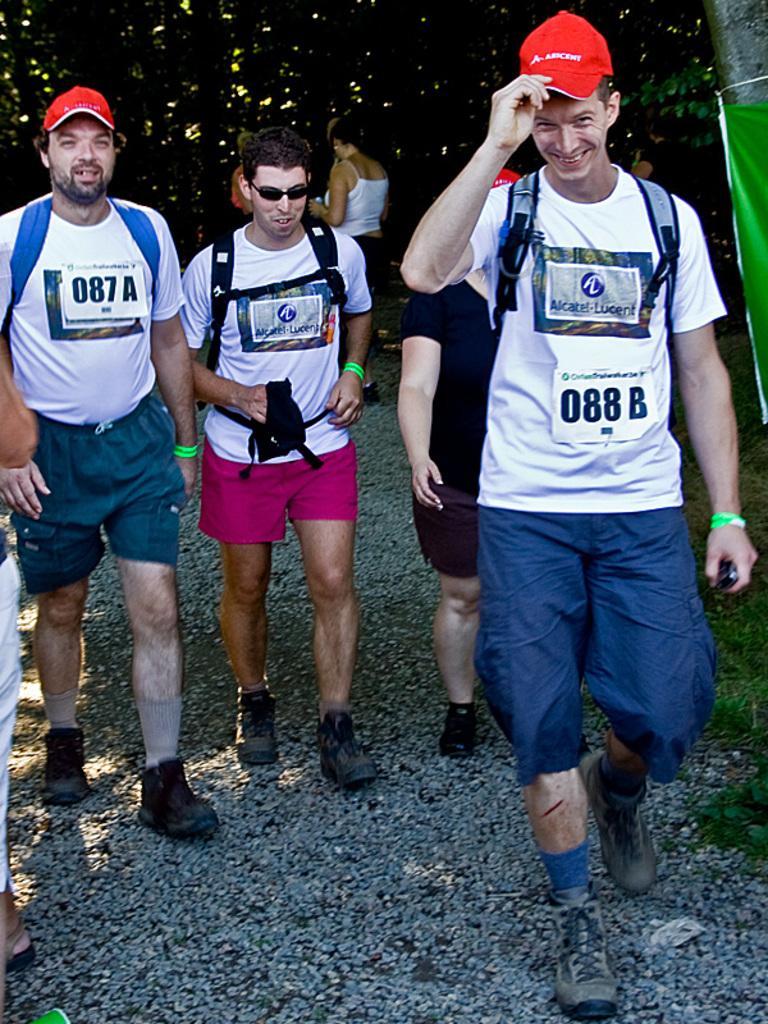Describe this image in one or two sentences. In this image there are some persons standing in middle of this image and the right side person is wearing white color t shirt and red color cap and wearing a backpack and left side to this person one another person wearing black color dress and black color shoes and there is an another person at left side to this person is wearing white color t shirt and black color backpack and black color shoes and one more person at left side is wearing white color t shirt and red color cap and black color shoes. there is one another person is at left side of this image and there is one other person standing at top of the image, there is one cloth in red color at right side of this image. 